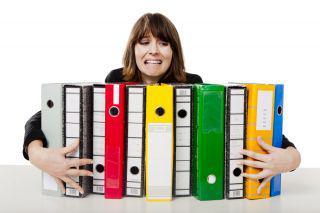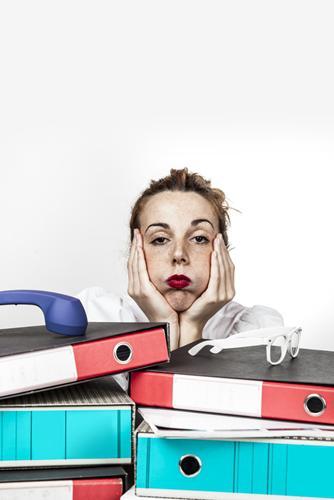The first image is the image on the left, the second image is the image on the right. Assess this claim about the two images: "A person is gripping multiple different colored binders in one of the images.". Correct or not? Answer yes or no. Yes. The first image is the image on the left, the second image is the image on the right. Given the left and right images, does the statement "There is a woman in the image on the right." hold true? Answer yes or no. Yes. 